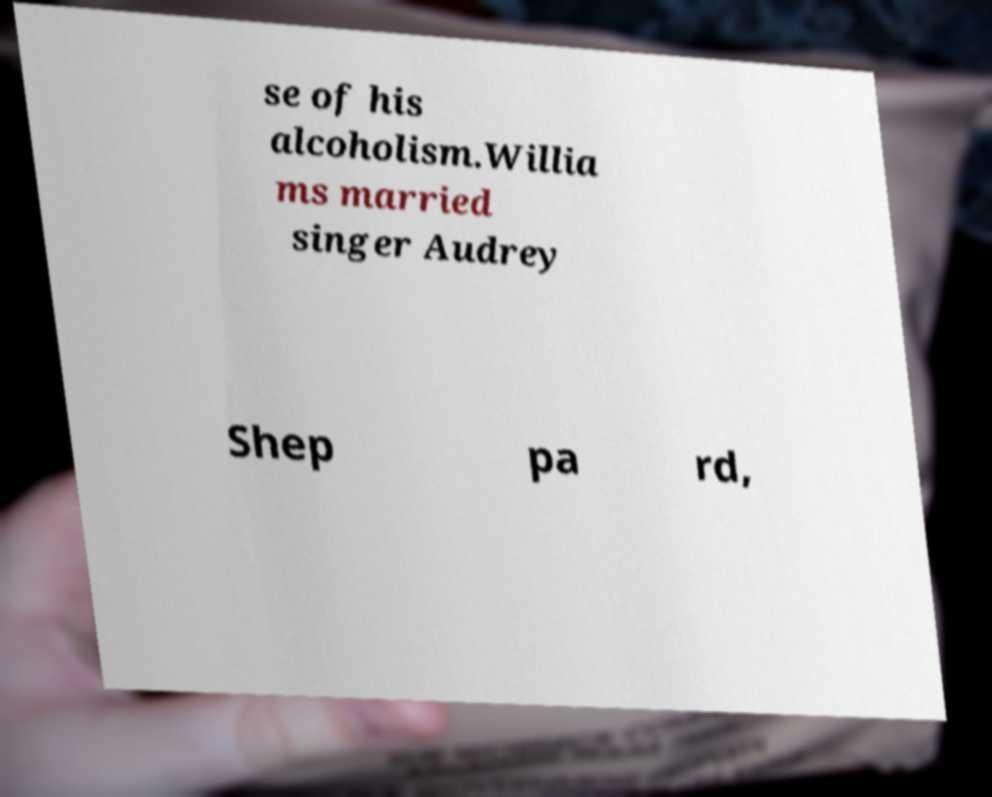Could you extract and type out the text from this image? se of his alcoholism.Willia ms married singer Audrey Shep pa rd, 